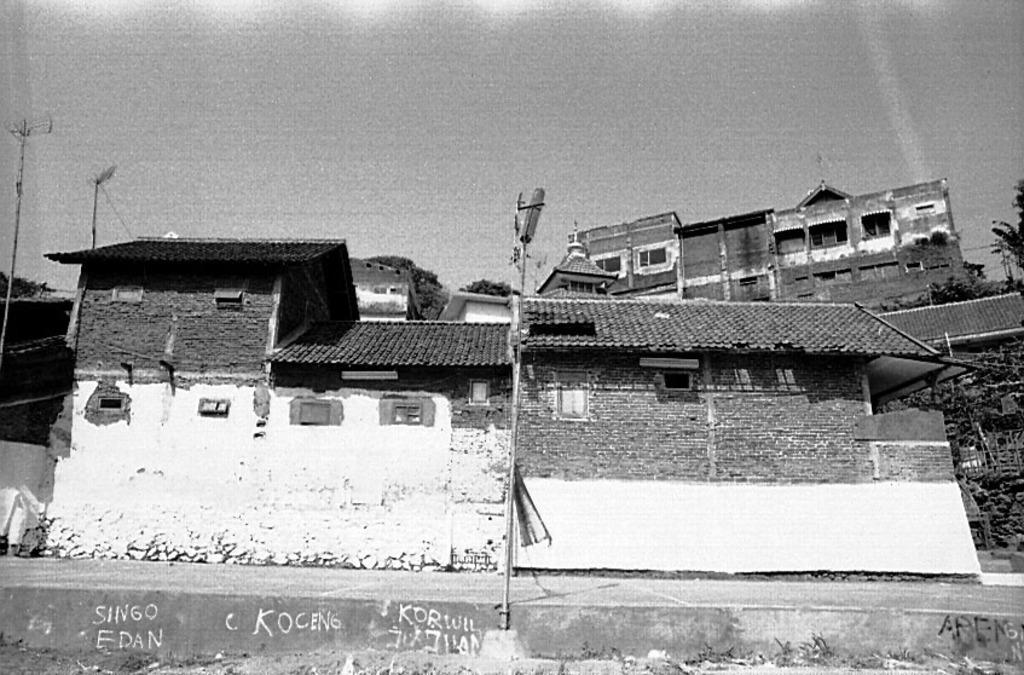What is the color scheme of the image? The image is black and white. What structure can be seen in the image? There is a pole in the image. What type of buildings are visible in the image? There are houses in the image. What can be seen in the background of the image? The sky is visible in the background of the image. Where is the basketball court located in the image? There is no basketball court present in the image. Can you describe the bath that is visible in the image? There is no bath present in the image. 